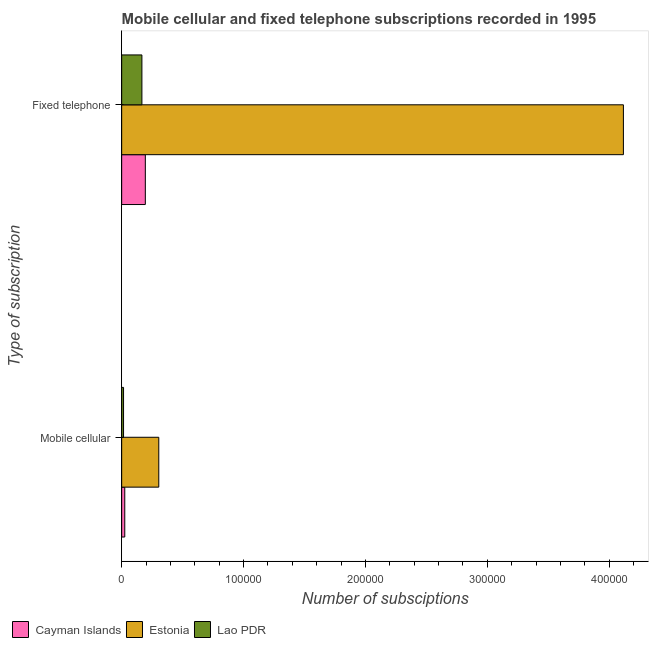Are the number of bars on each tick of the Y-axis equal?
Make the answer very short. Yes. How many bars are there on the 2nd tick from the bottom?
Offer a terse response. 3. What is the label of the 2nd group of bars from the top?
Offer a very short reply. Mobile cellular. What is the number of fixed telephone subscriptions in Cayman Islands?
Provide a succinct answer. 1.94e+04. Across all countries, what is the maximum number of mobile cellular subscriptions?
Provide a short and direct response. 3.05e+04. Across all countries, what is the minimum number of fixed telephone subscriptions?
Provide a succinct answer. 1.66e+04. In which country was the number of mobile cellular subscriptions maximum?
Make the answer very short. Estonia. In which country was the number of mobile cellular subscriptions minimum?
Your response must be concise. Lao PDR. What is the total number of fixed telephone subscriptions in the graph?
Make the answer very short. 4.48e+05. What is the difference between the number of mobile cellular subscriptions in Estonia and that in Cayman Islands?
Ensure brevity in your answer.  2.79e+04. What is the difference between the number of fixed telephone subscriptions in Lao PDR and the number of mobile cellular subscriptions in Cayman Islands?
Offer a terse response. 1.41e+04. What is the average number of fixed telephone subscriptions per country?
Offer a terse response. 1.49e+05. What is the difference between the number of fixed telephone subscriptions and number of mobile cellular subscriptions in Estonia?
Offer a very short reply. 3.81e+05. In how many countries, is the number of fixed telephone subscriptions greater than 260000 ?
Your response must be concise. 1. What is the ratio of the number of mobile cellular subscriptions in Cayman Islands to that in Lao PDR?
Offer a terse response. 1.65. Is the number of mobile cellular subscriptions in Cayman Islands less than that in Lao PDR?
Your response must be concise. No. In how many countries, is the number of fixed telephone subscriptions greater than the average number of fixed telephone subscriptions taken over all countries?
Give a very brief answer. 1. What does the 1st bar from the top in Mobile cellular represents?
Provide a succinct answer. Lao PDR. What does the 1st bar from the bottom in Mobile cellular represents?
Make the answer very short. Cayman Islands. How many bars are there?
Your answer should be very brief. 6. Are all the bars in the graph horizontal?
Offer a terse response. Yes. How many countries are there in the graph?
Offer a terse response. 3. Does the graph contain any zero values?
Provide a succinct answer. No. Does the graph contain grids?
Make the answer very short. No. How many legend labels are there?
Your answer should be very brief. 3. What is the title of the graph?
Keep it short and to the point. Mobile cellular and fixed telephone subscriptions recorded in 1995. What is the label or title of the X-axis?
Ensure brevity in your answer.  Number of subsciptions. What is the label or title of the Y-axis?
Ensure brevity in your answer.  Type of subscription. What is the Number of subsciptions in Cayman Islands in Mobile cellular?
Offer a very short reply. 2534. What is the Number of subsciptions of Estonia in Mobile cellular?
Your answer should be very brief. 3.05e+04. What is the Number of subsciptions in Lao PDR in Mobile cellular?
Ensure brevity in your answer.  1539. What is the Number of subsciptions of Cayman Islands in Fixed telephone?
Offer a very short reply. 1.94e+04. What is the Number of subsciptions of Estonia in Fixed telephone?
Offer a very short reply. 4.12e+05. What is the Number of subsciptions in Lao PDR in Fixed telephone?
Your answer should be compact. 1.66e+04. Across all Type of subscription, what is the maximum Number of subsciptions in Cayman Islands?
Make the answer very short. 1.94e+04. Across all Type of subscription, what is the maximum Number of subsciptions of Estonia?
Provide a succinct answer. 4.12e+05. Across all Type of subscription, what is the maximum Number of subsciptions in Lao PDR?
Offer a terse response. 1.66e+04. Across all Type of subscription, what is the minimum Number of subsciptions in Cayman Islands?
Your response must be concise. 2534. Across all Type of subscription, what is the minimum Number of subsciptions in Estonia?
Keep it short and to the point. 3.05e+04. Across all Type of subscription, what is the minimum Number of subsciptions of Lao PDR?
Give a very brief answer. 1539. What is the total Number of subsciptions in Cayman Islands in the graph?
Offer a very short reply. 2.19e+04. What is the total Number of subsciptions in Estonia in the graph?
Provide a short and direct response. 4.42e+05. What is the total Number of subsciptions in Lao PDR in the graph?
Provide a succinct answer. 1.81e+04. What is the difference between the Number of subsciptions of Cayman Islands in Mobile cellular and that in Fixed telephone?
Ensure brevity in your answer.  -1.69e+04. What is the difference between the Number of subsciptions in Estonia in Mobile cellular and that in Fixed telephone?
Your answer should be very brief. -3.81e+05. What is the difference between the Number of subsciptions of Lao PDR in Mobile cellular and that in Fixed telephone?
Make the answer very short. -1.51e+04. What is the difference between the Number of subsciptions in Cayman Islands in Mobile cellular and the Number of subsciptions in Estonia in Fixed telephone?
Give a very brief answer. -4.09e+05. What is the difference between the Number of subsciptions in Cayman Islands in Mobile cellular and the Number of subsciptions in Lao PDR in Fixed telephone?
Provide a succinct answer. -1.41e+04. What is the difference between the Number of subsciptions in Estonia in Mobile cellular and the Number of subsciptions in Lao PDR in Fixed telephone?
Your response must be concise. 1.38e+04. What is the average Number of subsciptions of Cayman Islands per Type of subscription?
Make the answer very short. 1.10e+04. What is the average Number of subsciptions of Estonia per Type of subscription?
Provide a short and direct response. 2.21e+05. What is the average Number of subsciptions in Lao PDR per Type of subscription?
Offer a very short reply. 9070.5. What is the difference between the Number of subsciptions of Cayman Islands and Number of subsciptions of Estonia in Mobile cellular?
Offer a very short reply. -2.79e+04. What is the difference between the Number of subsciptions of Cayman Islands and Number of subsciptions of Lao PDR in Mobile cellular?
Make the answer very short. 995. What is the difference between the Number of subsciptions in Estonia and Number of subsciptions in Lao PDR in Mobile cellular?
Offer a terse response. 2.89e+04. What is the difference between the Number of subsciptions in Cayman Islands and Number of subsciptions in Estonia in Fixed telephone?
Ensure brevity in your answer.  -3.92e+05. What is the difference between the Number of subsciptions of Cayman Islands and Number of subsciptions of Lao PDR in Fixed telephone?
Your response must be concise. 2808. What is the difference between the Number of subsciptions in Estonia and Number of subsciptions in Lao PDR in Fixed telephone?
Your answer should be very brief. 3.95e+05. What is the ratio of the Number of subsciptions of Cayman Islands in Mobile cellular to that in Fixed telephone?
Give a very brief answer. 0.13. What is the ratio of the Number of subsciptions of Estonia in Mobile cellular to that in Fixed telephone?
Ensure brevity in your answer.  0.07. What is the ratio of the Number of subsciptions in Lao PDR in Mobile cellular to that in Fixed telephone?
Make the answer very short. 0.09. What is the difference between the highest and the second highest Number of subsciptions in Cayman Islands?
Provide a short and direct response. 1.69e+04. What is the difference between the highest and the second highest Number of subsciptions of Estonia?
Keep it short and to the point. 3.81e+05. What is the difference between the highest and the second highest Number of subsciptions in Lao PDR?
Give a very brief answer. 1.51e+04. What is the difference between the highest and the lowest Number of subsciptions in Cayman Islands?
Offer a terse response. 1.69e+04. What is the difference between the highest and the lowest Number of subsciptions in Estonia?
Provide a short and direct response. 3.81e+05. What is the difference between the highest and the lowest Number of subsciptions of Lao PDR?
Make the answer very short. 1.51e+04. 